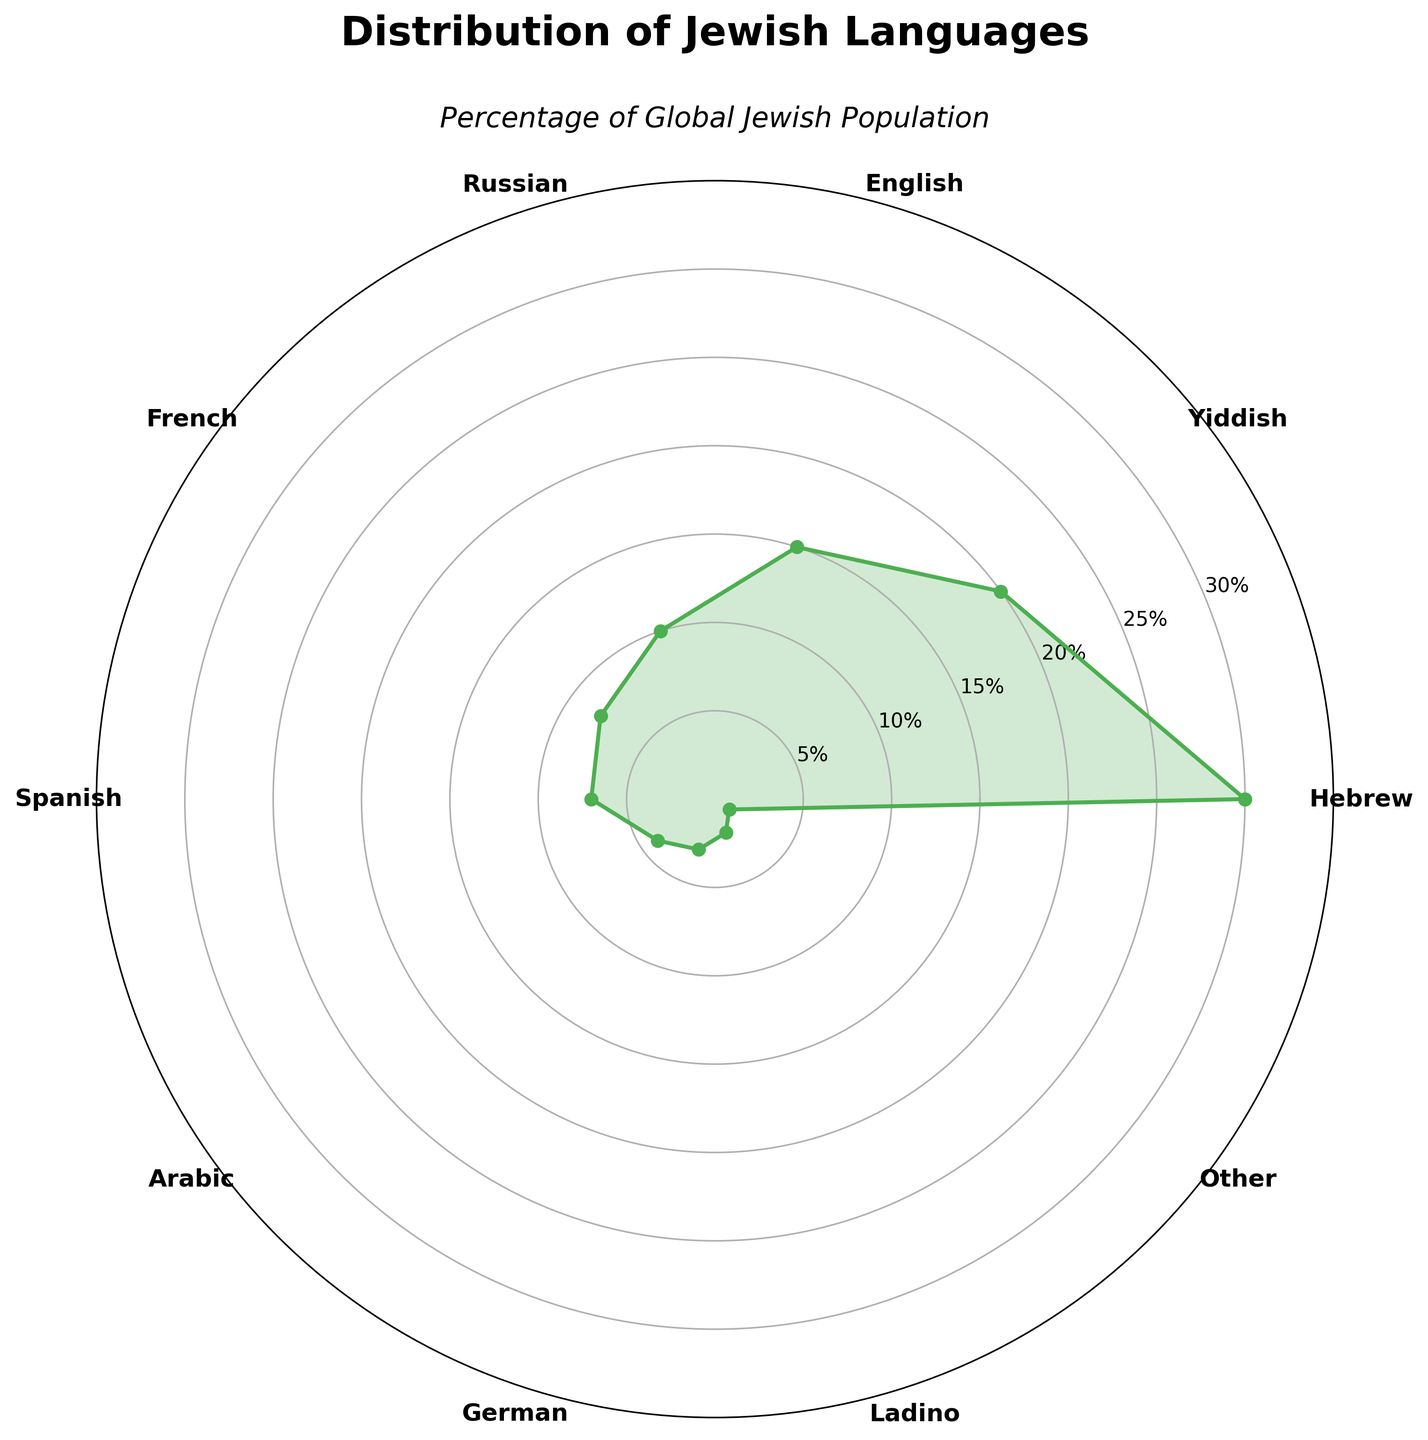What's the title of the figure? Look at the top of the figure where the title is located. The title is usually the most prominent text
Answer: Distribution of Jewish Languages What percentage of the global Jewish population speaks Hebrew? Find the section of the plot labeled 'Hebrew'. The value next to it is the percentage
Answer: 30% Which language is spoken by 20% of the global Jewish population? Look for the section of the plot labeled with the respective percentage value and identify the corresponding language
Answer: Yiddish What is the combined percentage of Jewish populations speaking Russian and French? Find the percentage values for Russian (10%) and French (8%). Sum these values
Answer: 18% Which language is spoken by fewer people: German or Ladino? Locate the percentages for German (3%) and Ladino (2%), and compare them
Answer: Ladino How many languages are represented in the figure? Count the number of different labels around the plot
Answer: 10 What is the percentage difference between speakers of English and Spanish? Subtract the percentage of Spanish speakers (7%) from the percentage of English speakers (15%)
Answer: 8% Which two languages have a total combined percentage of 11%? Identify the two languages with percentages that sum to 11%. These are Arabic (4%) and German (3%)
Answer: Arabic and German What is the smallest percentage represented in the figure, and which language does it correspond to? Look for the section with the smallest value, which is 1%, and find the corresponding language, 'Other'
Answer: 1%, Other Are there more speakers of French or Spanish among the global Jewish population? Compare the percentage values for French (8%) and Spanish (7%). French is higher
Answer: French 